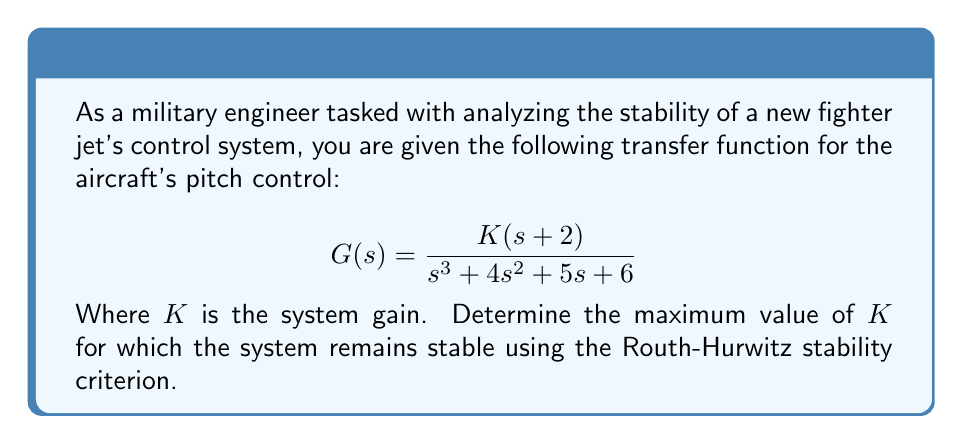Help me with this question. To analyze the stability of the system using the Routh-Hurwitz criterion, we need to construct the Routh array and determine the conditions for all elements in the first column to be positive.

1. First, let's write out the characteristic equation:
   $$s^3 + 4s^2 + 5s + (6+2K) = 0$$

2. Now, let's construct the Routh array:

   $$\begin{array}{c|c|c}
   s^3 & 1 & 5 \\
   s^2 & 4 & 6+2K \\
   s^1 & \frac{20-(6+2K)}{4} & 0 \\
   s^0 & 6+2K & 0
   \end{array}$$

3. For the system to be stable, all elements in the first column must be positive. We already know that the first two elements (1 and 4) are positive. Let's analyze the remaining two:

   For $s^1$ row: $\frac{20-(6+2K)}{4} > 0$
   $20-(6+2K) > 0$
   $14-2K > 0$
   $K < 7$

   For $s^0$ row: $6+2K > 0$
   $K > -3$

4. Combining these conditions, we get:
   $-3 < K < 7$

5. Since $K$ represents a gain, it should be positive. Therefore, the final range for $K$ is:
   $0 < K < 7$

Thus, the maximum value of $K$ for which the system remains stable is just under 7.
Answer: The maximum value of $K$ for which the system remains stable is $K_{max} = 7$ (approaching but not including 7). 